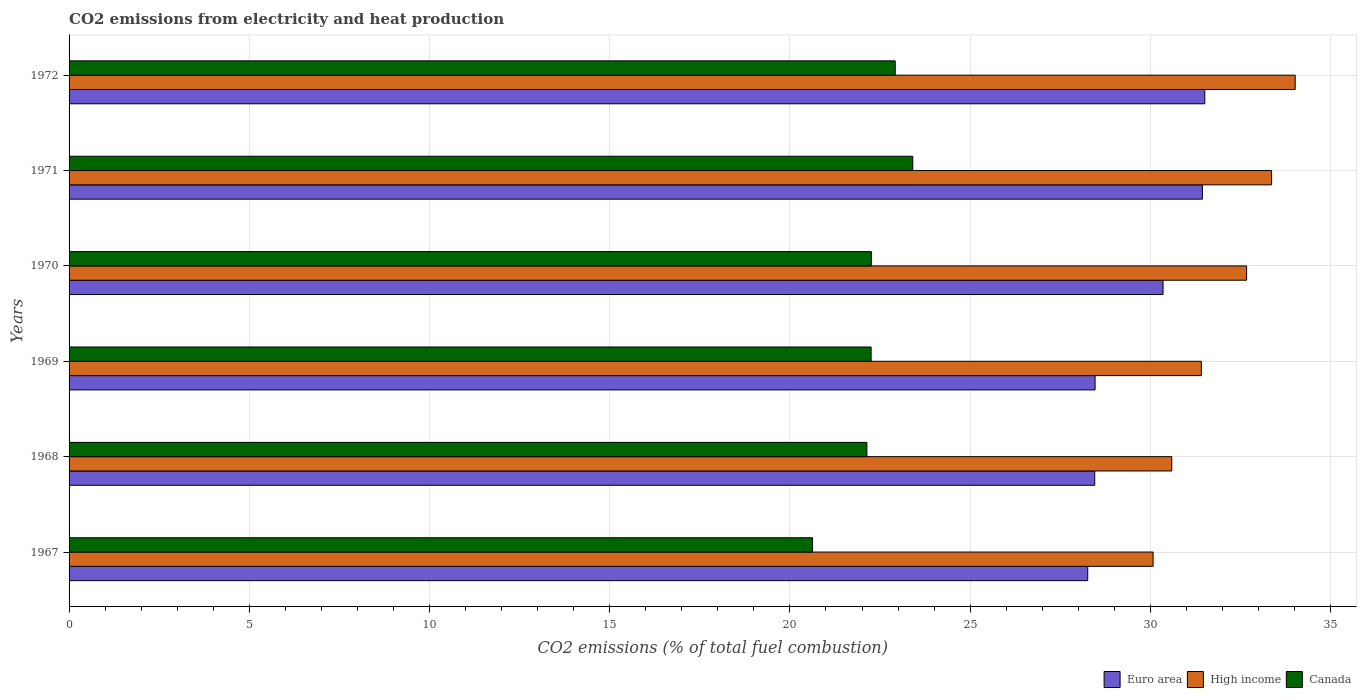How many different coloured bars are there?
Offer a terse response. 3. Are the number of bars per tick equal to the number of legend labels?
Give a very brief answer. Yes. What is the label of the 6th group of bars from the top?
Your response must be concise. 1967. In how many cases, is the number of bars for a given year not equal to the number of legend labels?
Your answer should be very brief. 0. What is the amount of CO2 emitted in Canada in 1969?
Provide a short and direct response. 22.25. Across all years, what is the maximum amount of CO2 emitted in Euro area?
Keep it short and to the point. 31.51. Across all years, what is the minimum amount of CO2 emitted in Canada?
Make the answer very short. 20.63. In which year was the amount of CO2 emitted in Canada maximum?
Give a very brief answer. 1971. In which year was the amount of CO2 emitted in Canada minimum?
Offer a very short reply. 1967. What is the total amount of CO2 emitted in Euro area in the graph?
Keep it short and to the point. 178.49. What is the difference between the amount of CO2 emitted in High income in 1967 and that in 1972?
Provide a succinct answer. -3.94. What is the difference between the amount of CO2 emitted in Canada in 1970 and the amount of CO2 emitted in High income in 1969?
Give a very brief answer. -9.16. What is the average amount of CO2 emitted in Euro area per year?
Give a very brief answer. 29.75. In the year 1970, what is the difference between the amount of CO2 emitted in Euro area and amount of CO2 emitted in High income?
Offer a very short reply. -2.32. What is the ratio of the amount of CO2 emitted in High income in 1969 to that in 1971?
Offer a very short reply. 0.94. What is the difference between the highest and the second highest amount of CO2 emitted in Canada?
Your answer should be compact. 0.49. What is the difference between the highest and the lowest amount of CO2 emitted in Euro area?
Provide a succinct answer. 3.25. Is the sum of the amount of CO2 emitted in High income in 1967 and 1972 greater than the maximum amount of CO2 emitted in Euro area across all years?
Your answer should be very brief. Yes. What does the 2nd bar from the top in 1969 represents?
Keep it short and to the point. High income. What does the 2nd bar from the bottom in 1969 represents?
Keep it short and to the point. High income. Is it the case that in every year, the sum of the amount of CO2 emitted in High income and amount of CO2 emitted in Canada is greater than the amount of CO2 emitted in Euro area?
Provide a short and direct response. Yes. Are all the bars in the graph horizontal?
Make the answer very short. Yes. Are the values on the major ticks of X-axis written in scientific E-notation?
Provide a short and direct response. No. Does the graph contain any zero values?
Your response must be concise. No. How many legend labels are there?
Offer a very short reply. 3. How are the legend labels stacked?
Keep it short and to the point. Horizontal. What is the title of the graph?
Offer a terse response. CO2 emissions from electricity and heat production. Does "Tanzania" appear as one of the legend labels in the graph?
Offer a very short reply. No. What is the label or title of the X-axis?
Offer a terse response. CO2 emissions (% of total fuel combustion). What is the label or title of the Y-axis?
Give a very brief answer. Years. What is the CO2 emissions (% of total fuel combustion) of Euro area in 1967?
Provide a short and direct response. 28.26. What is the CO2 emissions (% of total fuel combustion) of High income in 1967?
Your response must be concise. 30.08. What is the CO2 emissions (% of total fuel combustion) in Canada in 1967?
Keep it short and to the point. 20.63. What is the CO2 emissions (% of total fuel combustion) in Euro area in 1968?
Offer a terse response. 28.46. What is the CO2 emissions (% of total fuel combustion) of High income in 1968?
Offer a terse response. 30.59. What is the CO2 emissions (% of total fuel combustion) in Canada in 1968?
Offer a terse response. 22.13. What is the CO2 emissions (% of total fuel combustion) in Euro area in 1969?
Ensure brevity in your answer.  28.47. What is the CO2 emissions (% of total fuel combustion) in High income in 1969?
Ensure brevity in your answer.  31.41. What is the CO2 emissions (% of total fuel combustion) of Canada in 1969?
Make the answer very short. 22.25. What is the CO2 emissions (% of total fuel combustion) in Euro area in 1970?
Your answer should be very brief. 30.35. What is the CO2 emissions (% of total fuel combustion) of High income in 1970?
Keep it short and to the point. 32.67. What is the CO2 emissions (% of total fuel combustion) in Canada in 1970?
Offer a very short reply. 22.26. What is the CO2 emissions (% of total fuel combustion) in Euro area in 1971?
Your response must be concise. 31.44. What is the CO2 emissions (% of total fuel combustion) in High income in 1971?
Offer a terse response. 33.36. What is the CO2 emissions (% of total fuel combustion) of Canada in 1971?
Give a very brief answer. 23.41. What is the CO2 emissions (% of total fuel combustion) in Euro area in 1972?
Give a very brief answer. 31.51. What is the CO2 emissions (% of total fuel combustion) of High income in 1972?
Your response must be concise. 34.02. What is the CO2 emissions (% of total fuel combustion) of Canada in 1972?
Offer a terse response. 22.92. Across all years, what is the maximum CO2 emissions (% of total fuel combustion) in Euro area?
Ensure brevity in your answer.  31.51. Across all years, what is the maximum CO2 emissions (% of total fuel combustion) in High income?
Ensure brevity in your answer.  34.02. Across all years, what is the maximum CO2 emissions (% of total fuel combustion) in Canada?
Provide a short and direct response. 23.41. Across all years, what is the minimum CO2 emissions (% of total fuel combustion) in Euro area?
Offer a very short reply. 28.26. Across all years, what is the minimum CO2 emissions (% of total fuel combustion) of High income?
Ensure brevity in your answer.  30.08. Across all years, what is the minimum CO2 emissions (% of total fuel combustion) of Canada?
Offer a terse response. 20.63. What is the total CO2 emissions (% of total fuel combustion) in Euro area in the graph?
Give a very brief answer. 178.49. What is the total CO2 emissions (% of total fuel combustion) of High income in the graph?
Offer a very short reply. 192.13. What is the total CO2 emissions (% of total fuel combustion) of Canada in the graph?
Your answer should be compact. 133.6. What is the difference between the CO2 emissions (% of total fuel combustion) in Euro area in 1967 and that in 1968?
Give a very brief answer. -0.19. What is the difference between the CO2 emissions (% of total fuel combustion) of High income in 1967 and that in 1968?
Make the answer very short. -0.52. What is the difference between the CO2 emissions (% of total fuel combustion) in Canada in 1967 and that in 1968?
Ensure brevity in your answer.  -1.51. What is the difference between the CO2 emissions (% of total fuel combustion) of Euro area in 1967 and that in 1969?
Keep it short and to the point. -0.2. What is the difference between the CO2 emissions (% of total fuel combustion) in High income in 1967 and that in 1969?
Provide a succinct answer. -1.34. What is the difference between the CO2 emissions (% of total fuel combustion) in Canada in 1967 and that in 1969?
Make the answer very short. -1.62. What is the difference between the CO2 emissions (% of total fuel combustion) in Euro area in 1967 and that in 1970?
Your response must be concise. -2.09. What is the difference between the CO2 emissions (% of total fuel combustion) in High income in 1967 and that in 1970?
Keep it short and to the point. -2.59. What is the difference between the CO2 emissions (% of total fuel combustion) in Canada in 1967 and that in 1970?
Your answer should be very brief. -1.63. What is the difference between the CO2 emissions (% of total fuel combustion) of Euro area in 1967 and that in 1971?
Your response must be concise. -3.18. What is the difference between the CO2 emissions (% of total fuel combustion) of High income in 1967 and that in 1971?
Make the answer very short. -3.29. What is the difference between the CO2 emissions (% of total fuel combustion) of Canada in 1967 and that in 1971?
Your answer should be very brief. -2.78. What is the difference between the CO2 emissions (% of total fuel combustion) of Euro area in 1967 and that in 1972?
Ensure brevity in your answer.  -3.25. What is the difference between the CO2 emissions (% of total fuel combustion) of High income in 1967 and that in 1972?
Ensure brevity in your answer.  -3.94. What is the difference between the CO2 emissions (% of total fuel combustion) in Canada in 1967 and that in 1972?
Your answer should be compact. -2.29. What is the difference between the CO2 emissions (% of total fuel combustion) of Euro area in 1968 and that in 1969?
Your answer should be very brief. -0.01. What is the difference between the CO2 emissions (% of total fuel combustion) in High income in 1968 and that in 1969?
Provide a succinct answer. -0.82. What is the difference between the CO2 emissions (% of total fuel combustion) in Canada in 1968 and that in 1969?
Keep it short and to the point. -0.12. What is the difference between the CO2 emissions (% of total fuel combustion) in Euro area in 1968 and that in 1970?
Your answer should be very brief. -1.9. What is the difference between the CO2 emissions (% of total fuel combustion) in High income in 1968 and that in 1970?
Your answer should be very brief. -2.08. What is the difference between the CO2 emissions (% of total fuel combustion) of Canada in 1968 and that in 1970?
Provide a short and direct response. -0.12. What is the difference between the CO2 emissions (% of total fuel combustion) in Euro area in 1968 and that in 1971?
Make the answer very short. -2.99. What is the difference between the CO2 emissions (% of total fuel combustion) in High income in 1968 and that in 1971?
Your response must be concise. -2.77. What is the difference between the CO2 emissions (% of total fuel combustion) in Canada in 1968 and that in 1971?
Offer a very short reply. -1.27. What is the difference between the CO2 emissions (% of total fuel combustion) in Euro area in 1968 and that in 1972?
Your answer should be very brief. -3.05. What is the difference between the CO2 emissions (% of total fuel combustion) in High income in 1968 and that in 1972?
Make the answer very short. -3.42. What is the difference between the CO2 emissions (% of total fuel combustion) in Canada in 1968 and that in 1972?
Give a very brief answer. -0.79. What is the difference between the CO2 emissions (% of total fuel combustion) of Euro area in 1969 and that in 1970?
Make the answer very short. -1.89. What is the difference between the CO2 emissions (% of total fuel combustion) of High income in 1969 and that in 1970?
Provide a succinct answer. -1.26. What is the difference between the CO2 emissions (% of total fuel combustion) in Canada in 1969 and that in 1970?
Your response must be concise. -0.01. What is the difference between the CO2 emissions (% of total fuel combustion) of Euro area in 1969 and that in 1971?
Offer a terse response. -2.98. What is the difference between the CO2 emissions (% of total fuel combustion) of High income in 1969 and that in 1971?
Keep it short and to the point. -1.95. What is the difference between the CO2 emissions (% of total fuel combustion) in Canada in 1969 and that in 1971?
Offer a terse response. -1.16. What is the difference between the CO2 emissions (% of total fuel combustion) in Euro area in 1969 and that in 1972?
Give a very brief answer. -3.04. What is the difference between the CO2 emissions (% of total fuel combustion) in High income in 1969 and that in 1972?
Offer a terse response. -2.6. What is the difference between the CO2 emissions (% of total fuel combustion) in Canada in 1969 and that in 1972?
Your answer should be compact. -0.67. What is the difference between the CO2 emissions (% of total fuel combustion) in Euro area in 1970 and that in 1971?
Ensure brevity in your answer.  -1.09. What is the difference between the CO2 emissions (% of total fuel combustion) in High income in 1970 and that in 1971?
Provide a succinct answer. -0.69. What is the difference between the CO2 emissions (% of total fuel combustion) of Canada in 1970 and that in 1971?
Keep it short and to the point. -1.15. What is the difference between the CO2 emissions (% of total fuel combustion) of Euro area in 1970 and that in 1972?
Keep it short and to the point. -1.16. What is the difference between the CO2 emissions (% of total fuel combustion) of High income in 1970 and that in 1972?
Your answer should be very brief. -1.35. What is the difference between the CO2 emissions (% of total fuel combustion) in Canada in 1970 and that in 1972?
Your answer should be very brief. -0.66. What is the difference between the CO2 emissions (% of total fuel combustion) of Euro area in 1971 and that in 1972?
Your answer should be compact. -0.07. What is the difference between the CO2 emissions (% of total fuel combustion) of High income in 1971 and that in 1972?
Keep it short and to the point. -0.66. What is the difference between the CO2 emissions (% of total fuel combustion) of Canada in 1971 and that in 1972?
Your response must be concise. 0.49. What is the difference between the CO2 emissions (% of total fuel combustion) of Euro area in 1967 and the CO2 emissions (% of total fuel combustion) of High income in 1968?
Your answer should be very brief. -2.33. What is the difference between the CO2 emissions (% of total fuel combustion) in Euro area in 1967 and the CO2 emissions (% of total fuel combustion) in Canada in 1968?
Your answer should be very brief. 6.13. What is the difference between the CO2 emissions (% of total fuel combustion) of High income in 1967 and the CO2 emissions (% of total fuel combustion) of Canada in 1968?
Your response must be concise. 7.94. What is the difference between the CO2 emissions (% of total fuel combustion) in Euro area in 1967 and the CO2 emissions (% of total fuel combustion) in High income in 1969?
Keep it short and to the point. -3.15. What is the difference between the CO2 emissions (% of total fuel combustion) of Euro area in 1967 and the CO2 emissions (% of total fuel combustion) of Canada in 1969?
Your answer should be very brief. 6.01. What is the difference between the CO2 emissions (% of total fuel combustion) in High income in 1967 and the CO2 emissions (% of total fuel combustion) in Canada in 1969?
Make the answer very short. 7.82. What is the difference between the CO2 emissions (% of total fuel combustion) in Euro area in 1967 and the CO2 emissions (% of total fuel combustion) in High income in 1970?
Your answer should be very brief. -4.41. What is the difference between the CO2 emissions (% of total fuel combustion) in Euro area in 1967 and the CO2 emissions (% of total fuel combustion) in Canada in 1970?
Your answer should be very brief. 6. What is the difference between the CO2 emissions (% of total fuel combustion) of High income in 1967 and the CO2 emissions (% of total fuel combustion) of Canada in 1970?
Your answer should be compact. 7.82. What is the difference between the CO2 emissions (% of total fuel combustion) of Euro area in 1967 and the CO2 emissions (% of total fuel combustion) of High income in 1971?
Your response must be concise. -5.1. What is the difference between the CO2 emissions (% of total fuel combustion) of Euro area in 1967 and the CO2 emissions (% of total fuel combustion) of Canada in 1971?
Your response must be concise. 4.85. What is the difference between the CO2 emissions (% of total fuel combustion) of High income in 1967 and the CO2 emissions (% of total fuel combustion) of Canada in 1971?
Offer a terse response. 6.67. What is the difference between the CO2 emissions (% of total fuel combustion) of Euro area in 1967 and the CO2 emissions (% of total fuel combustion) of High income in 1972?
Your response must be concise. -5.76. What is the difference between the CO2 emissions (% of total fuel combustion) in Euro area in 1967 and the CO2 emissions (% of total fuel combustion) in Canada in 1972?
Keep it short and to the point. 5.34. What is the difference between the CO2 emissions (% of total fuel combustion) in High income in 1967 and the CO2 emissions (% of total fuel combustion) in Canada in 1972?
Your answer should be compact. 7.15. What is the difference between the CO2 emissions (% of total fuel combustion) of Euro area in 1968 and the CO2 emissions (% of total fuel combustion) of High income in 1969?
Give a very brief answer. -2.96. What is the difference between the CO2 emissions (% of total fuel combustion) of Euro area in 1968 and the CO2 emissions (% of total fuel combustion) of Canada in 1969?
Provide a succinct answer. 6.2. What is the difference between the CO2 emissions (% of total fuel combustion) of High income in 1968 and the CO2 emissions (% of total fuel combustion) of Canada in 1969?
Provide a short and direct response. 8.34. What is the difference between the CO2 emissions (% of total fuel combustion) in Euro area in 1968 and the CO2 emissions (% of total fuel combustion) in High income in 1970?
Your answer should be very brief. -4.21. What is the difference between the CO2 emissions (% of total fuel combustion) of Euro area in 1968 and the CO2 emissions (% of total fuel combustion) of Canada in 1970?
Provide a succinct answer. 6.2. What is the difference between the CO2 emissions (% of total fuel combustion) in High income in 1968 and the CO2 emissions (% of total fuel combustion) in Canada in 1970?
Give a very brief answer. 8.33. What is the difference between the CO2 emissions (% of total fuel combustion) of Euro area in 1968 and the CO2 emissions (% of total fuel combustion) of High income in 1971?
Offer a very short reply. -4.91. What is the difference between the CO2 emissions (% of total fuel combustion) in Euro area in 1968 and the CO2 emissions (% of total fuel combustion) in Canada in 1971?
Keep it short and to the point. 5.05. What is the difference between the CO2 emissions (% of total fuel combustion) in High income in 1968 and the CO2 emissions (% of total fuel combustion) in Canada in 1971?
Offer a terse response. 7.19. What is the difference between the CO2 emissions (% of total fuel combustion) of Euro area in 1968 and the CO2 emissions (% of total fuel combustion) of High income in 1972?
Provide a short and direct response. -5.56. What is the difference between the CO2 emissions (% of total fuel combustion) of Euro area in 1968 and the CO2 emissions (% of total fuel combustion) of Canada in 1972?
Your answer should be very brief. 5.54. What is the difference between the CO2 emissions (% of total fuel combustion) in High income in 1968 and the CO2 emissions (% of total fuel combustion) in Canada in 1972?
Keep it short and to the point. 7.67. What is the difference between the CO2 emissions (% of total fuel combustion) in Euro area in 1969 and the CO2 emissions (% of total fuel combustion) in High income in 1970?
Your response must be concise. -4.2. What is the difference between the CO2 emissions (% of total fuel combustion) of Euro area in 1969 and the CO2 emissions (% of total fuel combustion) of Canada in 1970?
Provide a succinct answer. 6.21. What is the difference between the CO2 emissions (% of total fuel combustion) of High income in 1969 and the CO2 emissions (% of total fuel combustion) of Canada in 1970?
Give a very brief answer. 9.16. What is the difference between the CO2 emissions (% of total fuel combustion) in Euro area in 1969 and the CO2 emissions (% of total fuel combustion) in High income in 1971?
Provide a succinct answer. -4.9. What is the difference between the CO2 emissions (% of total fuel combustion) of Euro area in 1969 and the CO2 emissions (% of total fuel combustion) of Canada in 1971?
Give a very brief answer. 5.06. What is the difference between the CO2 emissions (% of total fuel combustion) in High income in 1969 and the CO2 emissions (% of total fuel combustion) in Canada in 1971?
Make the answer very short. 8.01. What is the difference between the CO2 emissions (% of total fuel combustion) in Euro area in 1969 and the CO2 emissions (% of total fuel combustion) in High income in 1972?
Your answer should be compact. -5.55. What is the difference between the CO2 emissions (% of total fuel combustion) in Euro area in 1969 and the CO2 emissions (% of total fuel combustion) in Canada in 1972?
Provide a short and direct response. 5.55. What is the difference between the CO2 emissions (% of total fuel combustion) of High income in 1969 and the CO2 emissions (% of total fuel combustion) of Canada in 1972?
Make the answer very short. 8.49. What is the difference between the CO2 emissions (% of total fuel combustion) of Euro area in 1970 and the CO2 emissions (% of total fuel combustion) of High income in 1971?
Offer a terse response. -3.01. What is the difference between the CO2 emissions (% of total fuel combustion) of Euro area in 1970 and the CO2 emissions (% of total fuel combustion) of Canada in 1971?
Give a very brief answer. 6.94. What is the difference between the CO2 emissions (% of total fuel combustion) of High income in 1970 and the CO2 emissions (% of total fuel combustion) of Canada in 1971?
Give a very brief answer. 9.26. What is the difference between the CO2 emissions (% of total fuel combustion) of Euro area in 1970 and the CO2 emissions (% of total fuel combustion) of High income in 1972?
Offer a very short reply. -3.67. What is the difference between the CO2 emissions (% of total fuel combustion) in Euro area in 1970 and the CO2 emissions (% of total fuel combustion) in Canada in 1972?
Ensure brevity in your answer.  7.43. What is the difference between the CO2 emissions (% of total fuel combustion) in High income in 1970 and the CO2 emissions (% of total fuel combustion) in Canada in 1972?
Your answer should be compact. 9.75. What is the difference between the CO2 emissions (% of total fuel combustion) in Euro area in 1971 and the CO2 emissions (% of total fuel combustion) in High income in 1972?
Offer a very short reply. -2.57. What is the difference between the CO2 emissions (% of total fuel combustion) of Euro area in 1971 and the CO2 emissions (% of total fuel combustion) of Canada in 1972?
Provide a succinct answer. 8.52. What is the difference between the CO2 emissions (% of total fuel combustion) of High income in 1971 and the CO2 emissions (% of total fuel combustion) of Canada in 1972?
Provide a succinct answer. 10.44. What is the average CO2 emissions (% of total fuel combustion) in Euro area per year?
Your response must be concise. 29.75. What is the average CO2 emissions (% of total fuel combustion) of High income per year?
Provide a succinct answer. 32.02. What is the average CO2 emissions (% of total fuel combustion) in Canada per year?
Your response must be concise. 22.27. In the year 1967, what is the difference between the CO2 emissions (% of total fuel combustion) in Euro area and CO2 emissions (% of total fuel combustion) in High income?
Give a very brief answer. -1.81. In the year 1967, what is the difference between the CO2 emissions (% of total fuel combustion) in Euro area and CO2 emissions (% of total fuel combustion) in Canada?
Provide a short and direct response. 7.63. In the year 1967, what is the difference between the CO2 emissions (% of total fuel combustion) in High income and CO2 emissions (% of total fuel combustion) in Canada?
Your answer should be compact. 9.45. In the year 1968, what is the difference between the CO2 emissions (% of total fuel combustion) in Euro area and CO2 emissions (% of total fuel combustion) in High income?
Make the answer very short. -2.14. In the year 1968, what is the difference between the CO2 emissions (% of total fuel combustion) in Euro area and CO2 emissions (% of total fuel combustion) in Canada?
Ensure brevity in your answer.  6.32. In the year 1968, what is the difference between the CO2 emissions (% of total fuel combustion) in High income and CO2 emissions (% of total fuel combustion) in Canada?
Your answer should be compact. 8.46. In the year 1969, what is the difference between the CO2 emissions (% of total fuel combustion) of Euro area and CO2 emissions (% of total fuel combustion) of High income?
Make the answer very short. -2.95. In the year 1969, what is the difference between the CO2 emissions (% of total fuel combustion) of Euro area and CO2 emissions (% of total fuel combustion) of Canada?
Keep it short and to the point. 6.21. In the year 1969, what is the difference between the CO2 emissions (% of total fuel combustion) in High income and CO2 emissions (% of total fuel combustion) in Canada?
Offer a terse response. 9.16. In the year 1970, what is the difference between the CO2 emissions (% of total fuel combustion) in Euro area and CO2 emissions (% of total fuel combustion) in High income?
Provide a succinct answer. -2.32. In the year 1970, what is the difference between the CO2 emissions (% of total fuel combustion) of Euro area and CO2 emissions (% of total fuel combustion) of Canada?
Provide a short and direct response. 8.09. In the year 1970, what is the difference between the CO2 emissions (% of total fuel combustion) in High income and CO2 emissions (% of total fuel combustion) in Canada?
Provide a short and direct response. 10.41. In the year 1971, what is the difference between the CO2 emissions (% of total fuel combustion) in Euro area and CO2 emissions (% of total fuel combustion) in High income?
Your answer should be very brief. -1.92. In the year 1971, what is the difference between the CO2 emissions (% of total fuel combustion) in Euro area and CO2 emissions (% of total fuel combustion) in Canada?
Your answer should be compact. 8.04. In the year 1971, what is the difference between the CO2 emissions (% of total fuel combustion) of High income and CO2 emissions (% of total fuel combustion) of Canada?
Offer a terse response. 9.96. In the year 1972, what is the difference between the CO2 emissions (% of total fuel combustion) of Euro area and CO2 emissions (% of total fuel combustion) of High income?
Keep it short and to the point. -2.51. In the year 1972, what is the difference between the CO2 emissions (% of total fuel combustion) of Euro area and CO2 emissions (% of total fuel combustion) of Canada?
Ensure brevity in your answer.  8.59. In the year 1972, what is the difference between the CO2 emissions (% of total fuel combustion) of High income and CO2 emissions (% of total fuel combustion) of Canada?
Offer a terse response. 11.1. What is the ratio of the CO2 emissions (% of total fuel combustion) in High income in 1967 to that in 1968?
Your answer should be very brief. 0.98. What is the ratio of the CO2 emissions (% of total fuel combustion) of Canada in 1967 to that in 1968?
Ensure brevity in your answer.  0.93. What is the ratio of the CO2 emissions (% of total fuel combustion) in Euro area in 1967 to that in 1969?
Make the answer very short. 0.99. What is the ratio of the CO2 emissions (% of total fuel combustion) in High income in 1967 to that in 1969?
Make the answer very short. 0.96. What is the ratio of the CO2 emissions (% of total fuel combustion) in Canada in 1967 to that in 1969?
Your response must be concise. 0.93. What is the ratio of the CO2 emissions (% of total fuel combustion) of Euro area in 1967 to that in 1970?
Provide a succinct answer. 0.93. What is the ratio of the CO2 emissions (% of total fuel combustion) of High income in 1967 to that in 1970?
Provide a succinct answer. 0.92. What is the ratio of the CO2 emissions (% of total fuel combustion) of Canada in 1967 to that in 1970?
Provide a short and direct response. 0.93. What is the ratio of the CO2 emissions (% of total fuel combustion) in Euro area in 1967 to that in 1971?
Offer a very short reply. 0.9. What is the ratio of the CO2 emissions (% of total fuel combustion) of High income in 1967 to that in 1971?
Give a very brief answer. 0.9. What is the ratio of the CO2 emissions (% of total fuel combustion) in Canada in 1967 to that in 1971?
Ensure brevity in your answer.  0.88. What is the ratio of the CO2 emissions (% of total fuel combustion) in Euro area in 1967 to that in 1972?
Offer a very short reply. 0.9. What is the ratio of the CO2 emissions (% of total fuel combustion) in High income in 1967 to that in 1972?
Your answer should be very brief. 0.88. What is the ratio of the CO2 emissions (% of total fuel combustion) of High income in 1968 to that in 1969?
Ensure brevity in your answer.  0.97. What is the ratio of the CO2 emissions (% of total fuel combustion) in Canada in 1968 to that in 1969?
Give a very brief answer. 0.99. What is the ratio of the CO2 emissions (% of total fuel combustion) in Euro area in 1968 to that in 1970?
Ensure brevity in your answer.  0.94. What is the ratio of the CO2 emissions (% of total fuel combustion) of High income in 1968 to that in 1970?
Make the answer very short. 0.94. What is the ratio of the CO2 emissions (% of total fuel combustion) in Euro area in 1968 to that in 1971?
Your response must be concise. 0.91. What is the ratio of the CO2 emissions (% of total fuel combustion) in High income in 1968 to that in 1971?
Provide a succinct answer. 0.92. What is the ratio of the CO2 emissions (% of total fuel combustion) of Canada in 1968 to that in 1971?
Make the answer very short. 0.95. What is the ratio of the CO2 emissions (% of total fuel combustion) of Euro area in 1968 to that in 1972?
Provide a succinct answer. 0.9. What is the ratio of the CO2 emissions (% of total fuel combustion) of High income in 1968 to that in 1972?
Your answer should be compact. 0.9. What is the ratio of the CO2 emissions (% of total fuel combustion) of Canada in 1968 to that in 1972?
Keep it short and to the point. 0.97. What is the ratio of the CO2 emissions (% of total fuel combustion) of Euro area in 1969 to that in 1970?
Make the answer very short. 0.94. What is the ratio of the CO2 emissions (% of total fuel combustion) in High income in 1969 to that in 1970?
Offer a terse response. 0.96. What is the ratio of the CO2 emissions (% of total fuel combustion) of Euro area in 1969 to that in 1971?
Keep it short and to the point. 0.91. What is the ratio of the CO2 emissions (% of total fuel combustion) of High income in 1969 to that in 1971?
Give a very brief answer. 0.94. What is the ratio of the CO2 emissions (% of total fuel combustion) of Canada in 1969 to that in 1971?
Your response must be concise. 0.95. What is the ratio of the CO2 emissions (% of total fuel combustion) in Euro area in 1969 to that in 1972?
Give a very brief answer. 0.9. What is the ratio of the CO2 emissions (% of total fuel combustion) of High income in 1969 to that in 1972?
Ensure brevity in your answer.  0.92. What is the ratio of the CO2 emissions (% of total fuel combustion) in Canada in 1969 to that in 1972?
Your answer should be very brief. 0.97. What is the ratio of the CO2 emissions (% of total fuel combustion) in Euro area in 1970 to that in 1971?
Offer a terse response. 0.97. What is the ratio of the CO2 emissions (% of total fuel combustion) in High income in 1970 to that in 1971?
Give a very brief answer. 0.98. What is the ratio of the CO2 emissions (% of total fuel combustion) of Canada in 1970 to that in 1971?
Your response must be concise. 0.95. What is the ratio of the CO2 emissions (% of total fuel combustion) of Euro area in 1970 to that in 1972?
Ensure brevity in your answer.  0.96. What is the ratio of the CO2 emissions (% of total fuel combustion) of High income in 1970 to that in 1972?
Keep it short and to the point. 0.96. What is the ratio of the CO2 emissions (% of total fuel combustion) of Canada in 1970 to that in 1972?
Your answer should be very brief. 0.97. What is the ratio of the CO2 emissions (% of total fuel combustion) of Euro area in 1971 to that in 1972?
Your answer should be compact. 1. What is the ratio of the CO2 emissions (% of total fuel combustion) in High income in 1971 to that in 1972?
Give a very brief answer. 0.98. What is the ratio of the CO2 emissions (% of total fuel combustion) in Canada in 1971 to that in 1972?
Ensure brevity in your answer.  1.02. What is the difference between the highest and the second highest CO2 emissions (% of total fuel combustion) in Euro area?
Ensure brevity in your answer.  0.07. What is the difference between the highest and the second highest CO2 emissions (% of total fuel combustion) in High income?
Your answer should be compact. 0.66. What is the difference between the highest and the second highest CO2 emissions (% of total fuel combustion) of Canada?
Ensure brevity in your answer.  0.49. What is the difference between the highest and the lowest CO2 emissions (% of total fuel combustion) of Euro area?
Your answer should be very brief. 3.25. What is the difference between the highest and the lowest CO2 emissions (% of total fuel combustion) of High income?
Provide a short and direct response. 3.94. What is the difference between the highest and the lowest CO2 emissions (% of total fuel combustion) in Canada?
Keep it short and to the point. 2.78. 